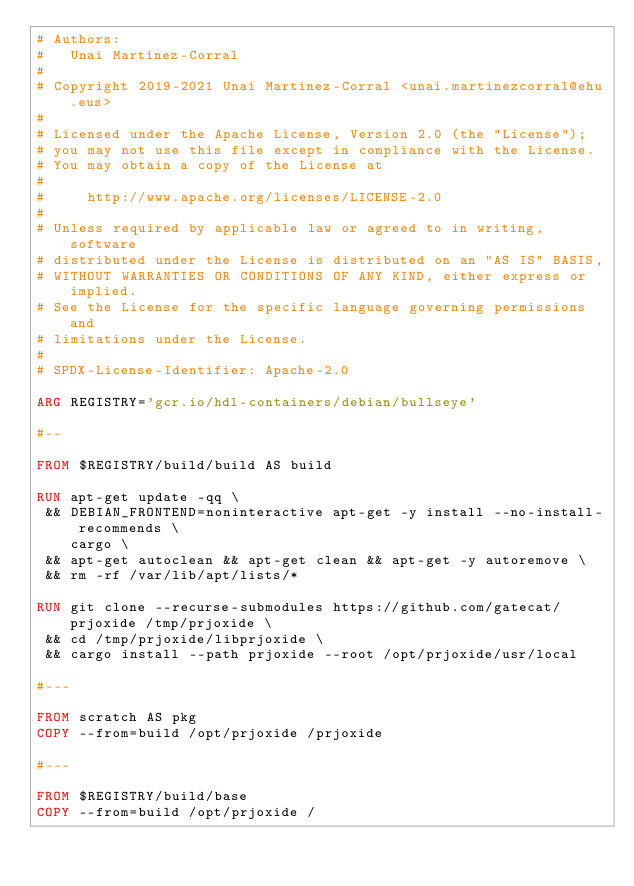<code> <loc_0><loc_0><loc_500><loc_500><_Dockerfile_># Authors:
#   Unai Martinez-Corral
#
# Copyright 2019-2021 Unai Martinez-Corral <unai.martinezcorral@ehu.eus>
#
# Licensed under the Apache License, Version 2.0 (the "License");
# you may not use this file except in compliance with the License.
# You may obtain a copy of the License at
#
#     http://www.apache.org/licenses/LICENSE-2.0
#
# Unless required by applicable law or agreed to in writing, software
# distributed under the License is distributed on an "AS IS" BASIS,
# WITHOUT WARRANTIES OR CONDITIONS OF ANY KIND, either express or implied.
# See the License for the specific language governing permissions and
# limitations under the License.
#
# SPDX-License-Identifier: Apache-2.0

ARG REGISTRY='gcr.io/hdl-containers/debian/bullseye'

#--

FROM $REGISTRY/build/build AS build

RUN apt-get update -qq \
 && DEBIAN_FRONTEND=noninteractive apt-get -y install --no-install-recommends \
    cargo \
 && apt-get autoclean && apt-get clean && apt-get -y autoremove \
 && rm -rf /var/lib/apt/lists/*

RUN git clone --recurse-submodules https://github.com/gatecat/prjoxide /tmp/prjoxide \
 && cd /tmp/prjoxide/libprjoxide \
 && cargo install --path prjoxide --root /opt/prjoxide/usr/local

#---

FROM scratch AS pkg
COPY --from=build /opt/prjoxide /prjoxide

#---

FROM $REGISTRY/build/base
COPY --from=build /opt/prjoxide /
</code> 